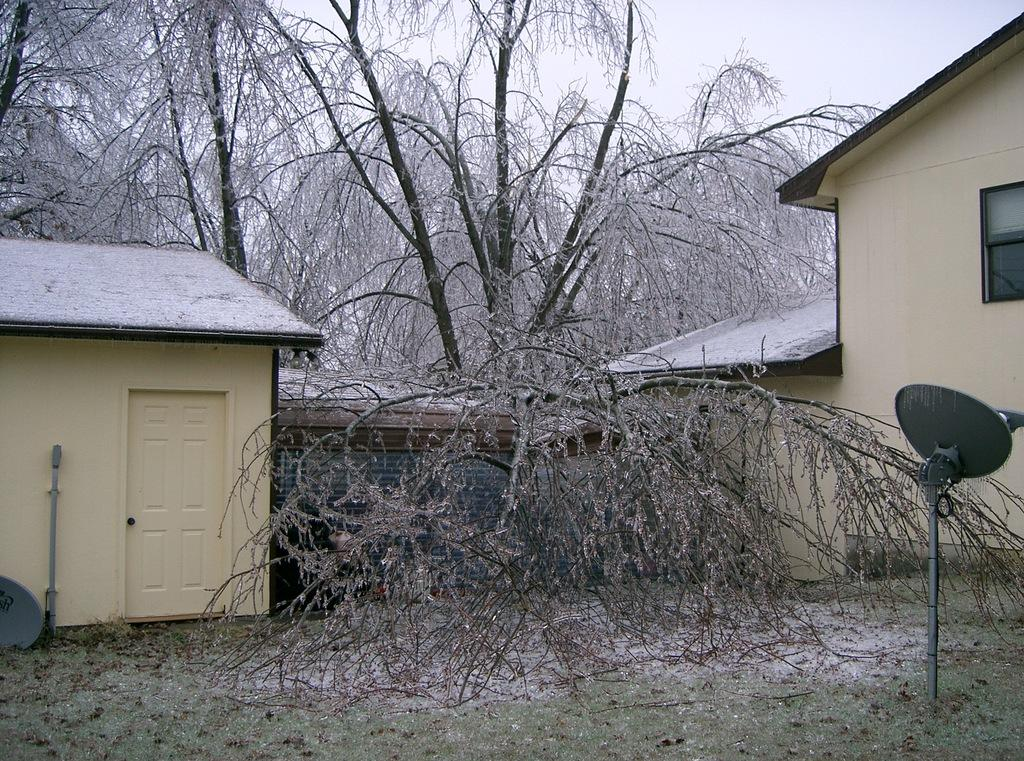How many buildings can be seen in the image? There are two cream-colored buildings in the image. What is the condition of the trees in the image? The trees in the image are dried. What color is the sky in the image? The sky is white in color. Can you see a blade of grass in the image? There is no blade of grass visible in the image. Is there is any steam coming from the buildings in the image? There is no steam present in the image. 